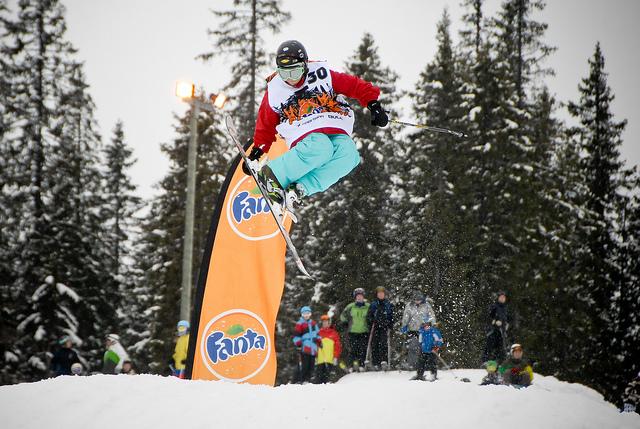Is this person in the air?
Give a very brief answer. Yes. Is Fanta sponsoring the ski event?
Quick response, please. Yes. Where is written on the flag?
Concise answer only. Fanta. 